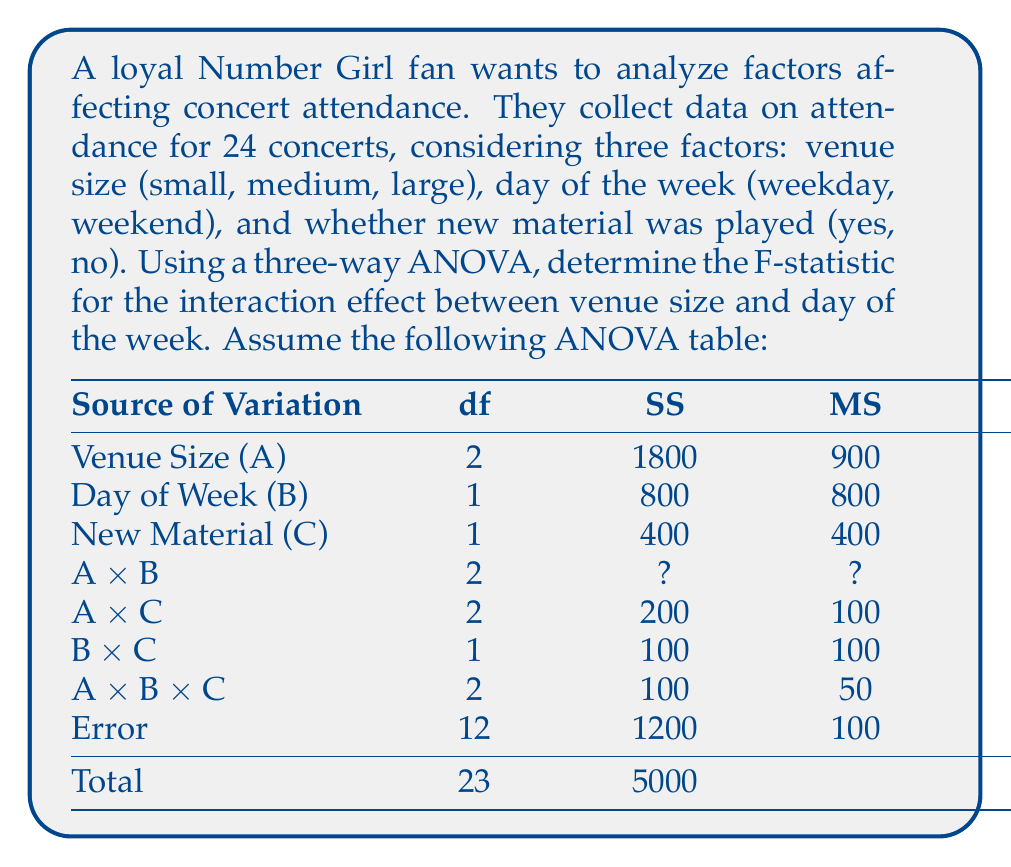Can you solve this math problem? To find the F-statistic for the interaction effect between venue size and day of the week (A x B), we need to follow these steps:

1. Calculate the Sum of Squares (SS) for A x B:
   Total SS = 5000
   SS accounted for = 1800 + 800 + 400 + 200 + 100 + 100 + 1200 = 4600
   SS for A x B = 5000 - 4600 = 400

2. Calculate the Mean Square (MS) for A x B:
   $MS_{A \times B} = \frac{SS_{A \times B}}{df_{A \times B}} = \frac{400}{2} = 200$

3. Calculate the F-statistic:
   $F_{A \times B} = \frac{MS_{A \times B}}{MS_{Error}} = \frac{200}{100} = 2$

Therefore, the F-statistic for the interaction effect between venue size and day of the week is 2.

This result suggests that there might be a moderate interaction effect between venue size and day of the week on Number Girl concert attendance. However, to determine if this effect is statistically significant, we would need to compare this F-value to the critical F-value at the chosen significance level.
Answer: The F-statistic for the interaction effect between venue size and day of the week is 2. 